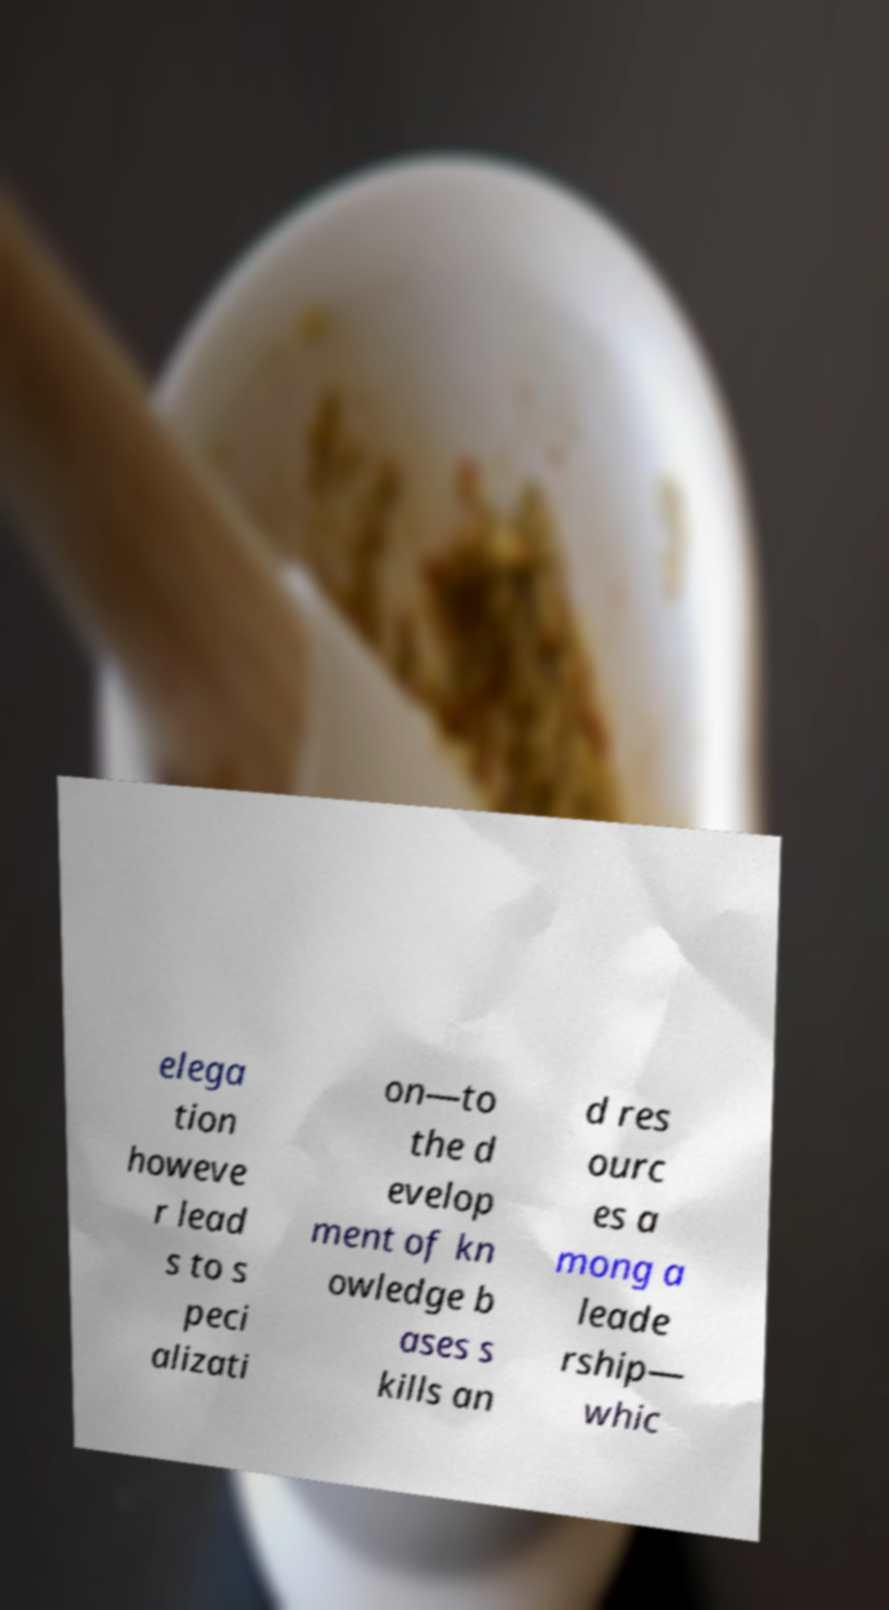Could you extract and type out the text from this image? elega tion howeve r lead s to s peci alizati on—to the d evelop ment of kn owledge b ases s kills an d res ourc es a mong a leade rship— whic 